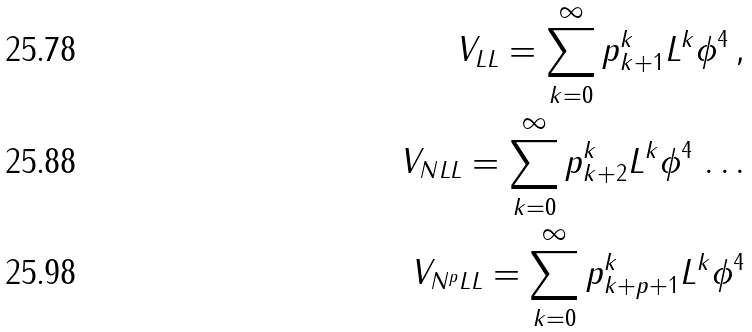Convert formula to latex. <formula><loc_0><loc_0><loc_500><loc_500>V _ { L L } = \sum ^ { \infty } _ { k = 0 } p ^ { k } _ { k + 1 } L ^ { k } \phi ^ { 4 } \, , \\ V _ { N L L } = \sum ^ { \infty } _ { k = 0 } p ^ { k } _ { k + 2 } L ^ { k } \phi ^ { 4 } \, \dots \\ V _ { N ^ { p } L L } = \sum ^ { \infty } _ { k = 0 } p ^ { k } _ { k + p + 1 } L ^ { k } \phi ^ { 4 }</formula> 